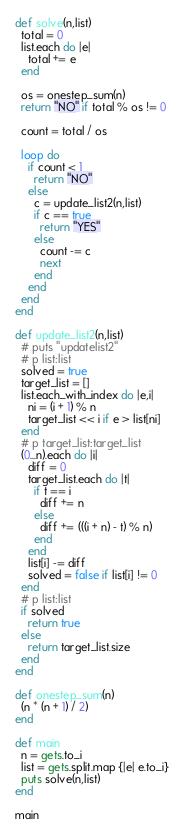<code> <loc_0><loc_0><loc_500><loc_500><_Ruby_>def solve(n,list)
  total = 0
  list.each do |e|
    total += e
  end

  os = onestep_sum(n)
  return "NO" if total % os != 0

  count = total / os

  loop do
    if count < 1
      return "NO"
    else
      c = update_list2(n,list)
      if c == true
        return "YES"
      else
        count -= c
        next
      end
    end
  end
end

def update_list2(n,list)
  # puts "updatelist2"
  # p list:list
  solved = true
  target_list = []
  list.each_with_index do |e,i|
    ni = (i + 1) % n
    target_list << i if e > list[ni]
  end
  # p target_list:target_list
  (0...n).each do |i|
    diff = 0
    target_list.each do |t|
      if t == i
        diff += n
      else
        diff += (((i + n) - t) % n)
      end
    end
    list[i] -= diff
    solved = false if list[i] != 0
  end
  # p list:list
  if solved
    return true
  else
    return target_list.size
  end
end

def onestep_sum(n)
  (n * (n + 1) / 2)
end

def main
  n = gets.to_i
  list = gets.split.map {|e| e.to_i}
  puts solve(n,list)
end

main
</code> 